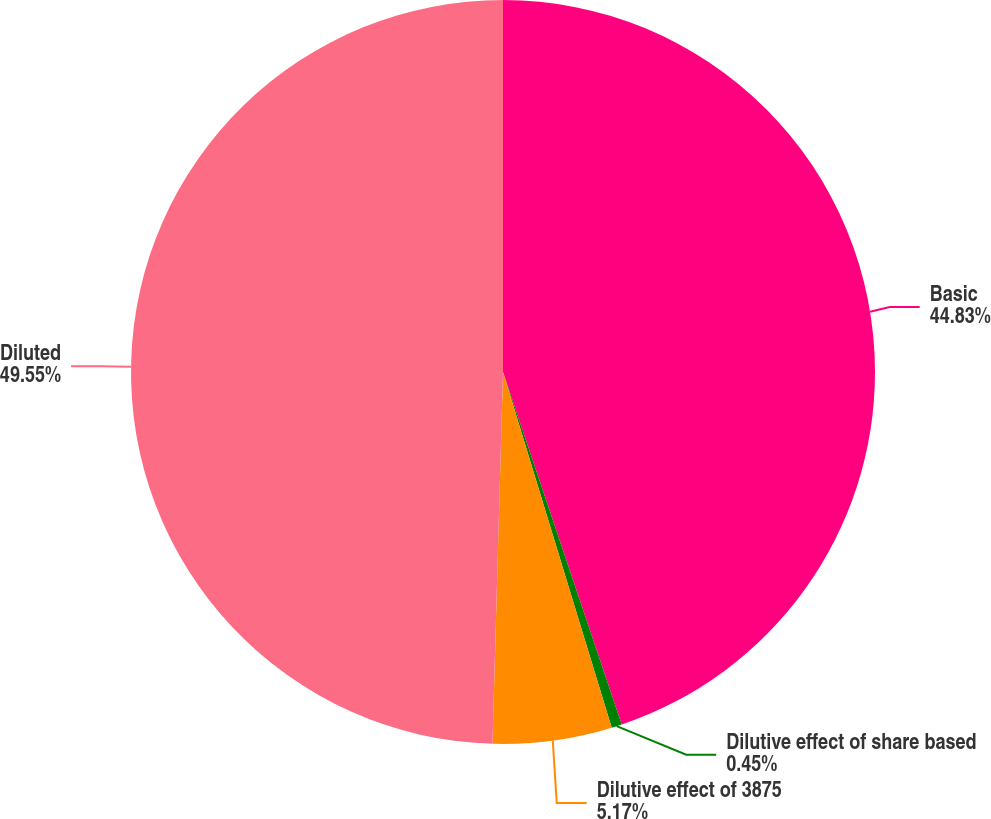Convert chart. <chart><loc_0><loc_0><loc_500><loc_500><pie_chart><fcel>Basic<fcel>Dilutive effect of share based<fcel>Dilutive effect of 3875<fcel>Diluted<nl><fcel>44.83%<fcel>0.45%<fcel>5.17%<fcel>49.55%<nl></chart> 